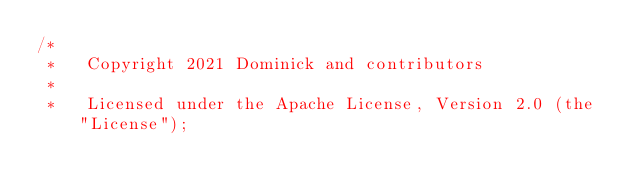Convert code to text. <code><loc_0><loc_0><loc_500><loc_500><_Kotlin_>/*
 *   Copyright 2021 Dominick and contributors
 *
 *   Licensed under the Apache License, Version 2.0 (the "License");</code> 